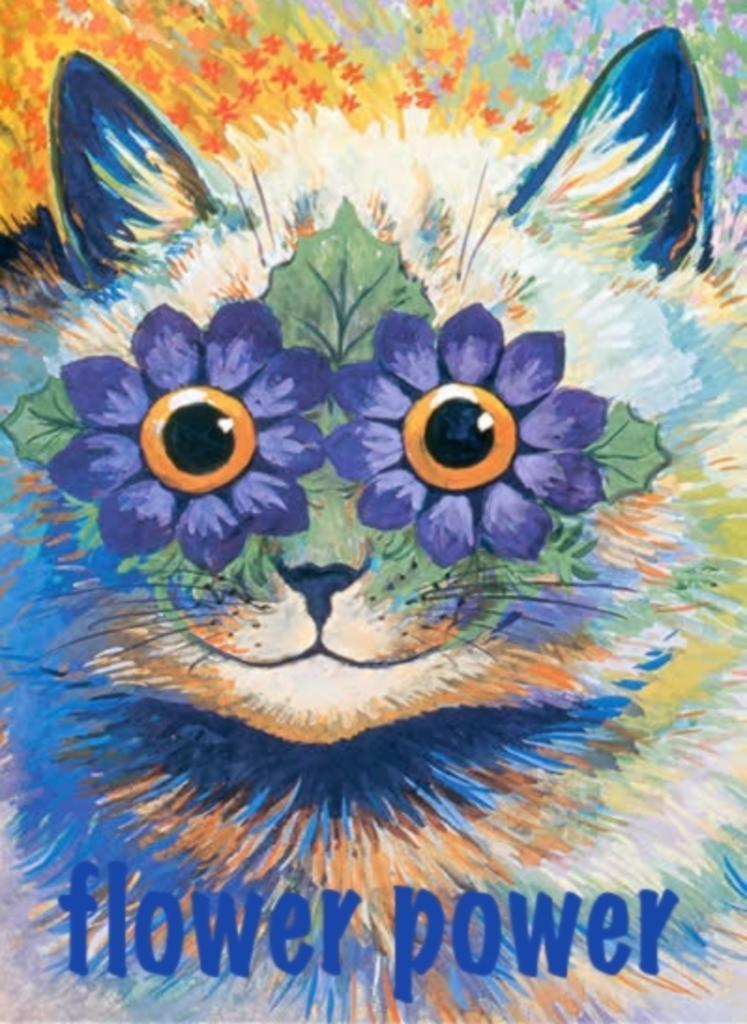Please provide a concise description of this image. In this picture we can see the painting of a cat. Here we can see the flowers. At the bottom there is a watermark. 